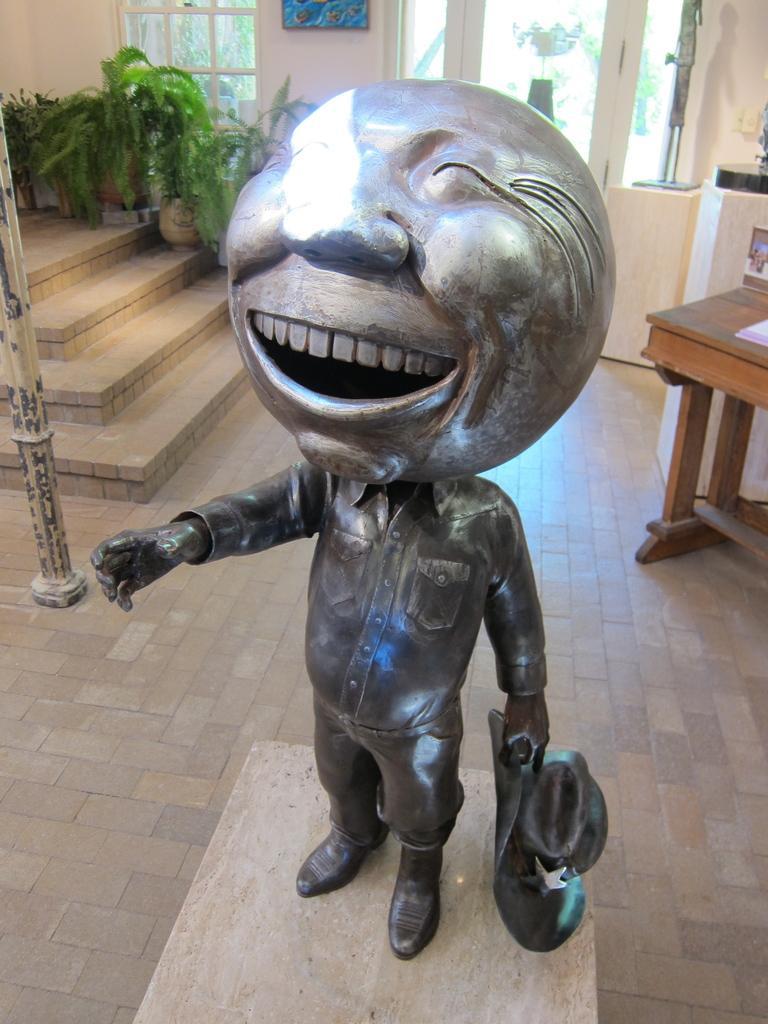Please provide a concise description of this image. There is a statue of a person who is holding a hat in his hand and his head is in round shape. 